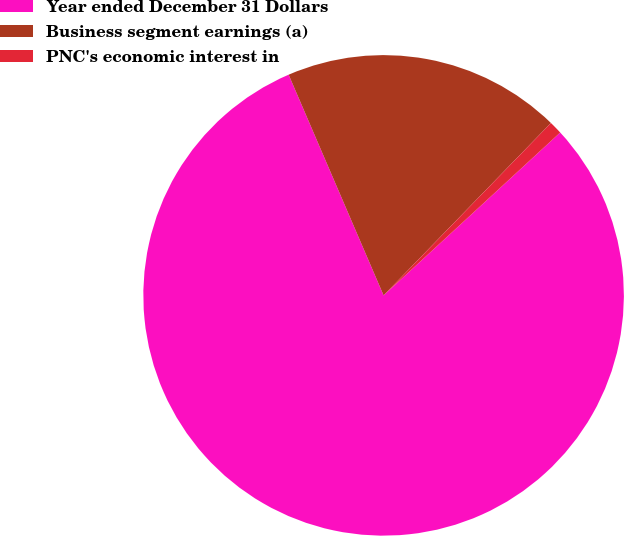Convert chart. <chart><loc_0><loc_0><loc_500><loc_500><pie_chart><fcel>Year ended December 31 Dollars<fcel>Business segment earnings (a)<fcel>PNC's economic interest in<nl><fcel>80.39%<fcel>18.73%<fcel>0.88%<nl></chart> 